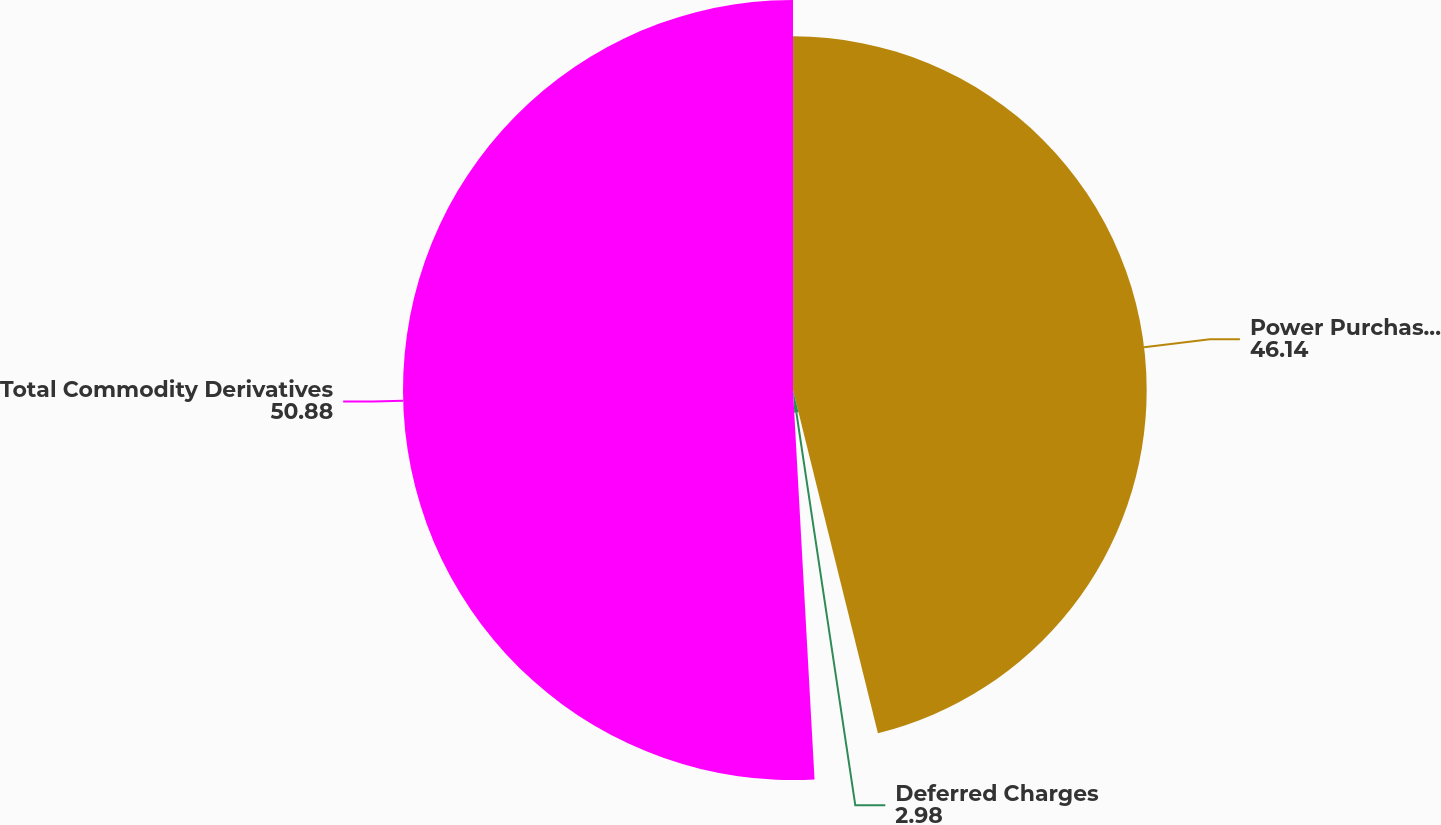<chart> <loc_0><loc_0><loc_500><loc_500><pie_chart><fcel>Power Purchase Contract Asset<fcel>Deferred Charges<fcel>Total Commodity Derivatives<nl><fcel>46.14%<fcel>2.98%<fcel>50.88%<nl></chart> 